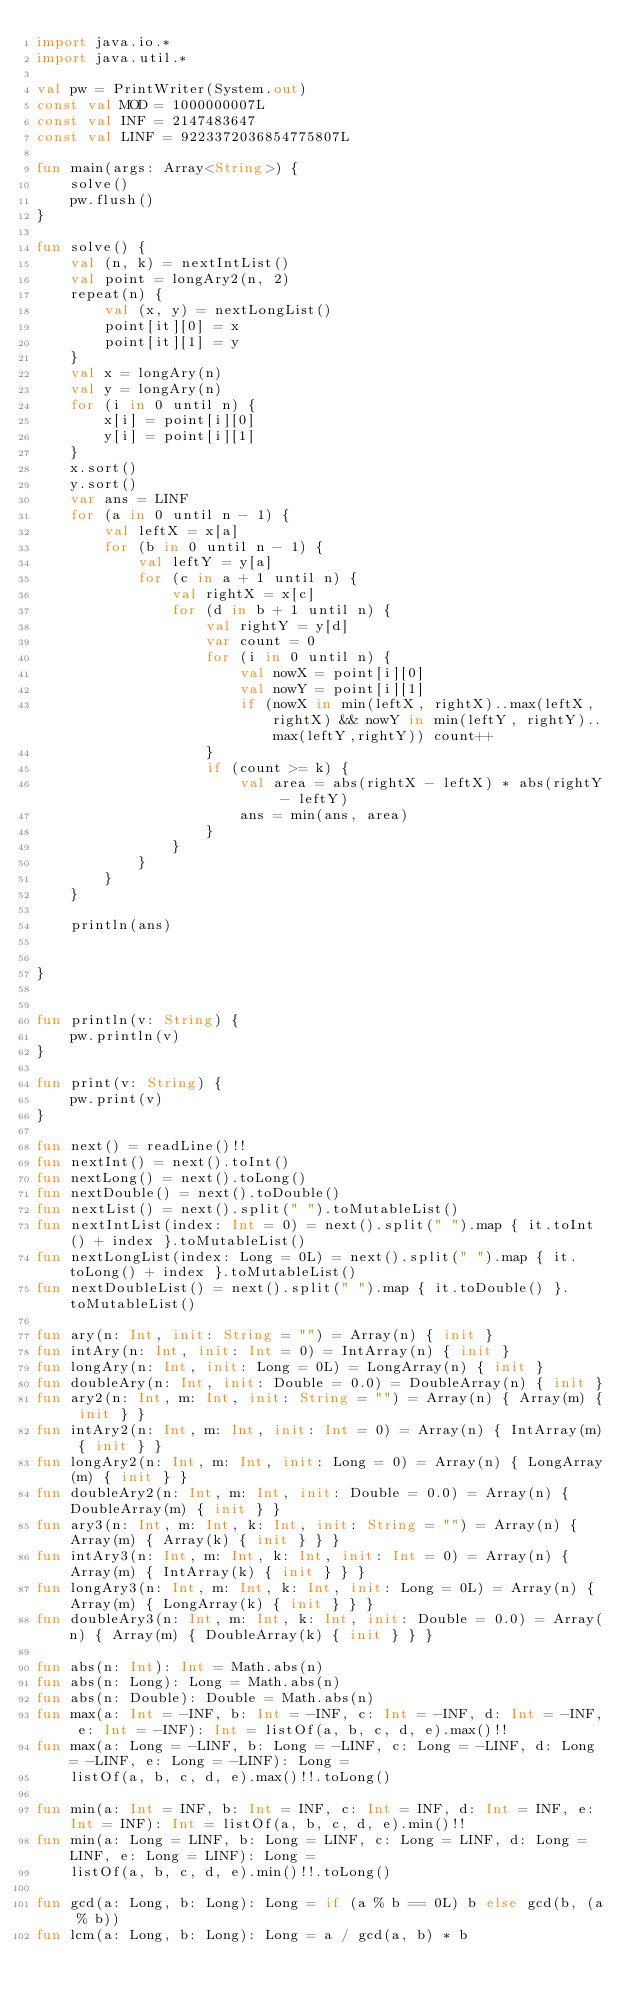<code> <loc_0><loc_0><loc_500><loc_500><_Kotlin_>import java.io.*
import java.util.*

val pw = PrintWriter(System.out)
const val MOD = 1000000007L
const val INF = 2147483647
const val LINF = 9223372036854775807L

fun main(args: Array<String>) {
    solve()
    pw.flush()
}

fun solve() {
    val (n, k) = nextIntList()
    val point = longAry2(n, 2)
    repeat(n) {
        val (x, y) = nextLongList()
        point[it][0] = x
        point[it][1] = y
    }
    val x = longAry(n)
    val y = longAry(n)
    for (i in 0 until n) {
        x[i] = point[i][0]
        y[i] = point[i][1]
    }
    x.sort()
    y.sort()
    var ans = LINF
    for (a in 0 until n - 1) {
        val leftX = x[a]
        for (b in 0 until n - 1) {
            val leftY = y[a]
            for (c in a + 1 until n) {
                val rightX = x[c]
                for (d in b + 1 until n) {
                    val rightY = y[d]
                    var count = 0
                    for (i in 0 until n) {
                        val nowX = point[i][0]
                        val nowY = point[i][1]
                        if (nowX in min(leftX, rightX)..max(leftX, rightX) && nowY in min(leftY, rightY)..max(leftY,rightY)) count++
                    }
                    if (count >= k) {
                        val area = abs(rightX - leftX) * abs(rightY - leftY)
                        ans = min(ans, area)
                    }
                }
            }
        }
    }

    println(ans)


}


fun println(v: String) {
    pw.println(v)
}

fun print(v: String) {
    pw.print(v)
}

fun next() = readLine()!!
fun nextInt() = next().toInt()
fun nextLong() = next().toLong()
fun nextDouble() = next().toDouble()
fun nextList() = next().split(" ").toMutableList()
fun nextIntList(index: Int = 0) = next().split(" ").map { it.toInt() + index }.toMutableList()
fun nextLongList(index: Long = 0L) = next().split(" ").map { it.toLong() + index }.toMutableList()
fun nextDoubleList() = next().split(" ").map { it.toDouble() }.toMutableList()

fun ary(n: Int, init: String = "") = Array(n) { init }
fun intAry(n: Int, init: Int = 0) = IntArray(n) { init }
fun longAry(n: Int, init: Long = 0L) = LongArray(n) { init }
fun doubleAry(n: Int, init: Double = 0.0) = DoubleArray(n) { init }
fun ary2(n: Int, m: Int, init: String = "") = Array(n) { Array(m) { init } }
fun intAry2(n: Int, m: Int, init: Int = 0) = Array(n) { IntArray(m) { init } }
fun longAry2(n: Int, m: Int, init: Long = 0) = Array(n) { LongArray(m) { init } }
fun doubleAry2(n: Int, m: Int, init: Double = 0.0) = Array(n) { DoubleArray(m) { init } }
fun ary3(n: Int, m: Int, k: Int, init: String = "") = Array(n) { Array(m) { Array(k) { init } } }
fun intAry3(n: Int, m: Int, k: Int, init: Int = 0) = Array(n) { Array(m) { IntArray(k) { init } } }
fun longAry3(n: Int, m: Int, k: Int, init: Long = 0L) = Array(n) { Array(m) { LongArray(k) { init } } }
fun doubleAry3(n: Int, m: Int, k: Int, init: Double = 0.0) = Array(n) { Array(m) { DoubleArray(k) { init } } }

fun abs(n: Int): Int = Math.abs(n)
fun abs(n: Long): Long = Math.abs(n)
fun abs(n: Double): Double = Math.abs(n)
fun max(a: Int = -INF, b: Int = -INF, c: Int = -INF, d: Int = -INF, e: Int = -INF): Int = listOf(a, b, c, d, e).max()!!
fun max(a: Long = -LINF, b: Long = -LINF, c: Long = -LINF, d: Long = -LINF, e: Long = -LINF): Long =
    listOf(a, b, c, d, e).max()!!.toLong()

fun min(a: Int = INF, b: Int = INF, c: Int = INF, d: Int = INF, e: Int = INF): Int = listOf(a, b, c, d, e).min()!!
fun min(a: Long = LINF, b: Long = LINF, c: Long = LINF, d: Long = LINF, e: Long = LINF): Long =
    listOf(a, b, c, d, e).min()!!.toLong()

fun gcd(a: Long, b: Long): Long = if (a % b == 0L) b else gcd(b, (a % b))
fun lcm(a: Long, b: Long): Long = a / gcd(a, b) * b</code> 